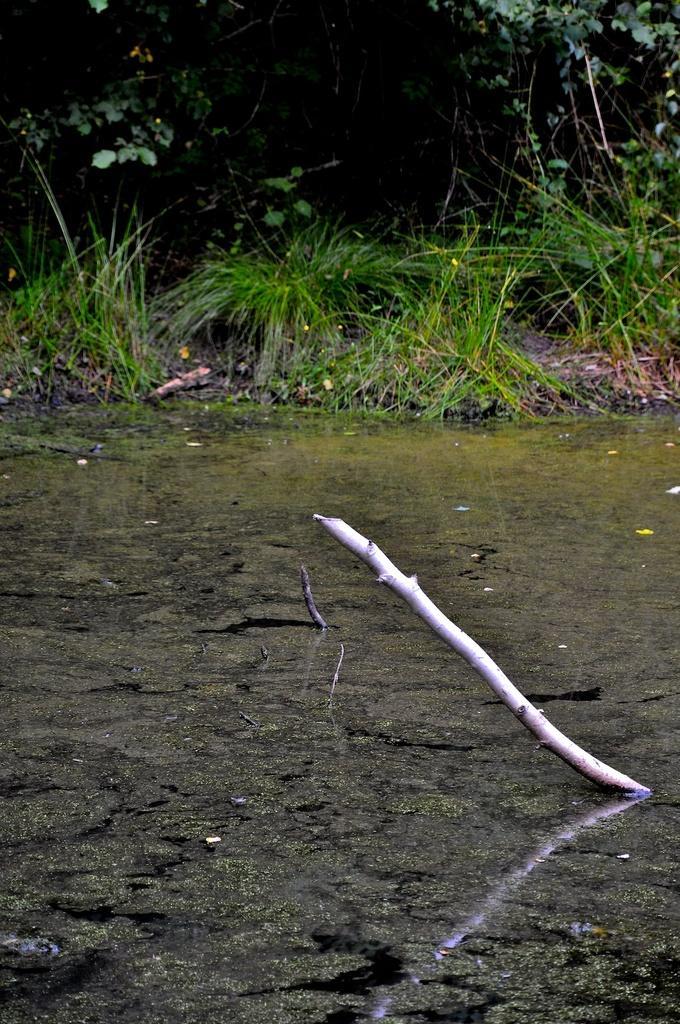Could you give a brief overview of what you see in this image? This image consists of a stick. There is water in the middle. There is grass in the middle. There are trees at the top. 